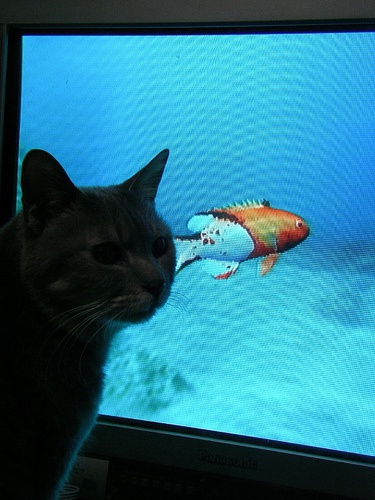Describe the objects in this image and their specific colors. I can see tv in black and lightblue tones and cat in black, darkblue, teal, and lightblue tones in this image. 